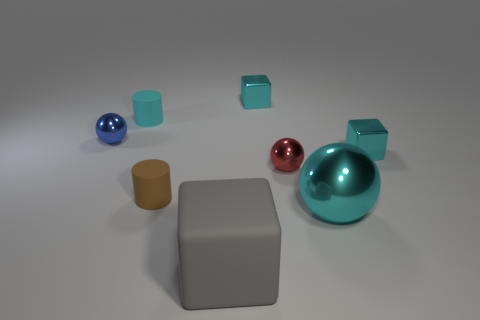There is a blue object that is the same shape as the small red object; what is its size?
Offer a terse response. Small. Is the large ball the same color as the large rubber cube?
Make the answer very short. No. What is the color of the shiny object that is to the left of the red thing and in front of the small cyan cylinder?
Your answer should be compact. Blue. What number of things are either balls on the right side of the tiny red shiny object or cyan rubber blocks?
Keep it short and to the point. 1. There is another object that is the same shape as the cyan rubber thing; what color is it?
Keep it short and to the point. Brown. Is the shape of the small red thing the same as the small shiny object behind the tiny cyan matte thing?
Keep it short and to the point. No. How many things are matte things to the right of the tiny brown thing or tiny cyan cubes behind the tiny blue ball?
Ensure brevity in your answer.  2. Is the number of gray matte blocks behind the cyan metal sphere less than the number of blue metal objects?
Keep it short and to the point. Yes. Does the tiny brown thing have the same material as the ball that is to the left of the gray object?
Your answer should be very brief. No. What is the cyan sphere made of?
Provide a succinct answer. Metal. 